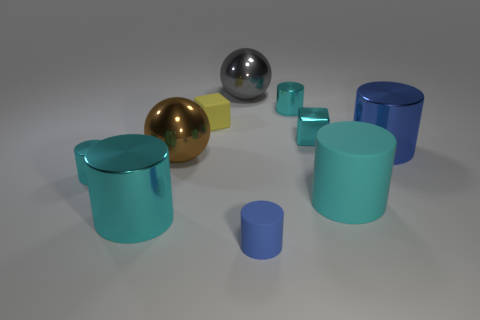Subtract all small matte cylinders. How many cylinders are left? 5 Subtract all purple balls. How many cyan cylinders are left? 4 Subtract all yellow cubes. How many cubes are left? 1 Subtract 3 cylinders. How many cylinders are left? 3 Subtract 1 yellow cubes. How many objects are left? 9 Subtract all cylinders. How many objects are left? 4 Subtract all cyan cylinders. Subtract all red balls. How many cylinders are left? 2 Subtract all blue metal cylinders. Subtract all red metallic objects. How many objects are left? 9 Add 1 cyan metal blocks. How many cyan metal blocks are left? 2 Add 8 large blue rubber balls. How many large blue rubber balls exist? 8 